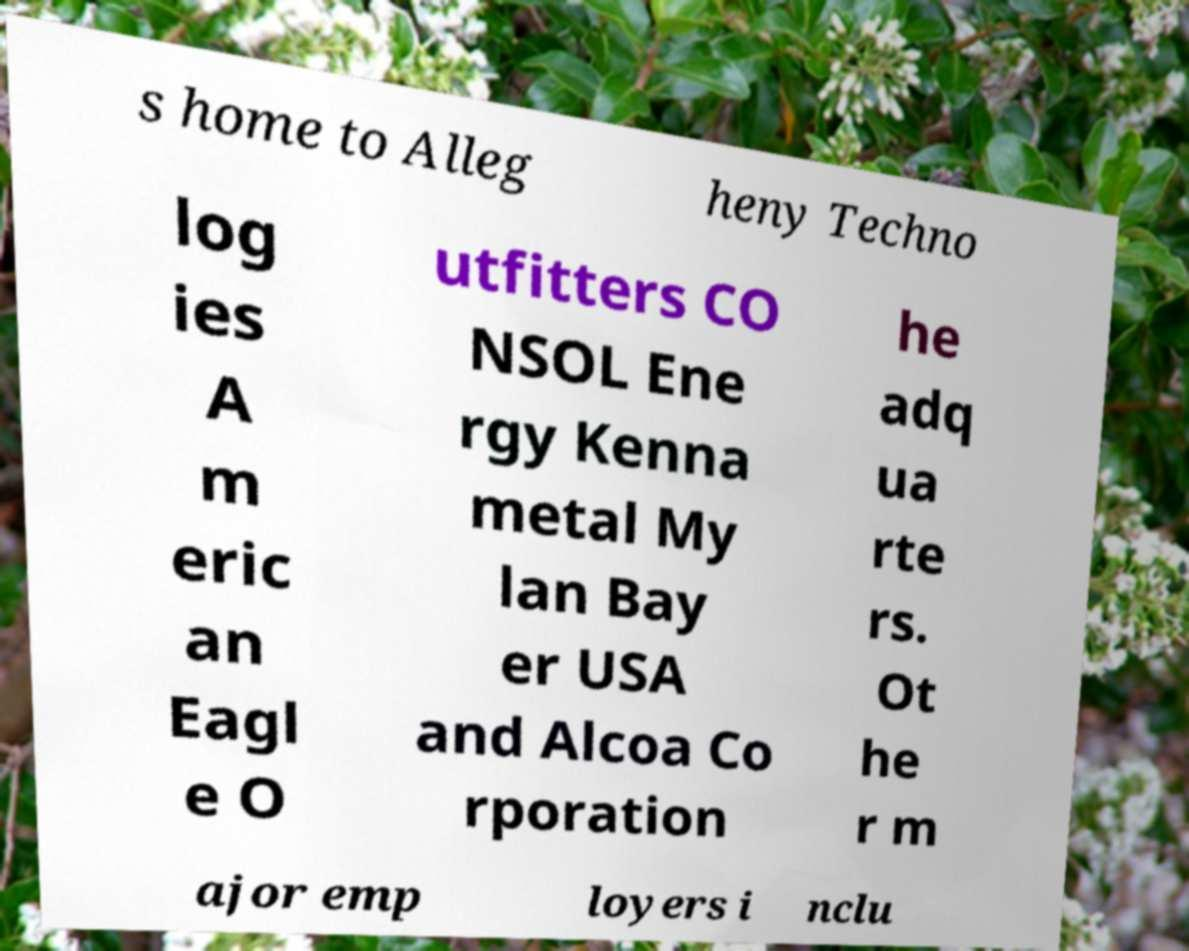Could you extract and type out the text from this image? s home to Alleg heny Techno log ies A m eric an Eagl e O utfitters CO NSOL Ene rgy Kenna metal My lan Bay er USA and Alcoa Co rporation he adq ua rte rs. Ot he r m ajor emp loyers i nclu 